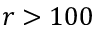Convert formula to latex. <formula><loc_0><loc_0><loc_500><loc_500>r > 1 0 0</formula> 